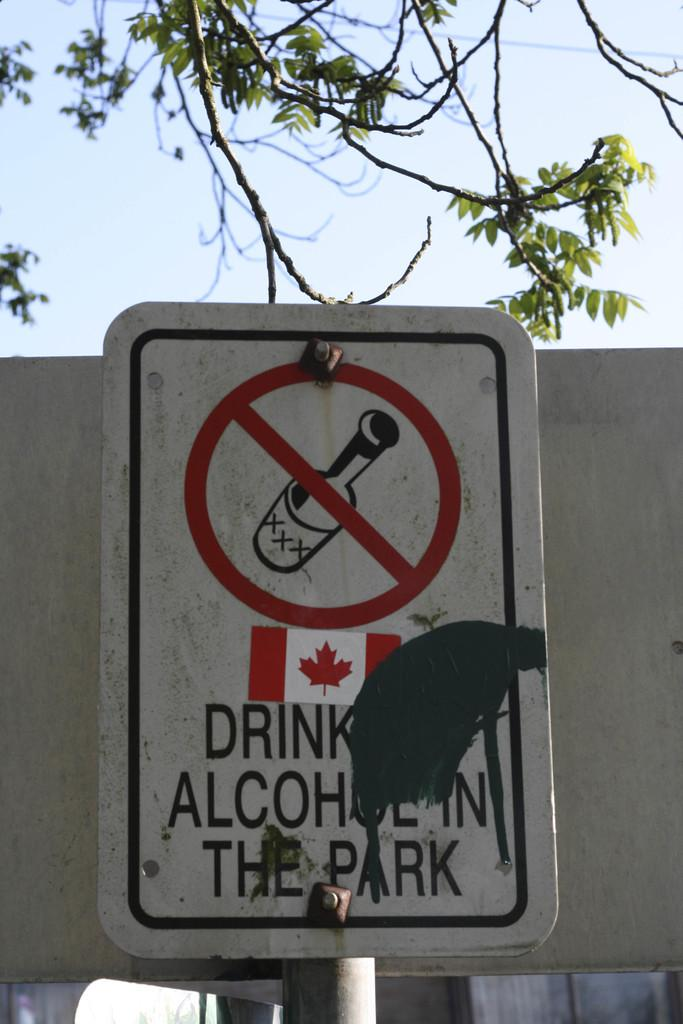What is the main object in the image? There is a sign board in the image. What can be seen in the background of the image? The sky is visible in the image. What type of natural elements are present in the image? There are trees in the image. What type of toys can be seen on the sign board in the image? There are no toys present on the sign board in the image. 